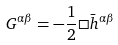Convert formula to latex. <formula><loc_0><loc_0><loc_500><loc_500>G ^ { \alpha \beta } = - \frac { 1 } { 2 } \Box \bar { h } ^ { \alpha \beta }</formula> 